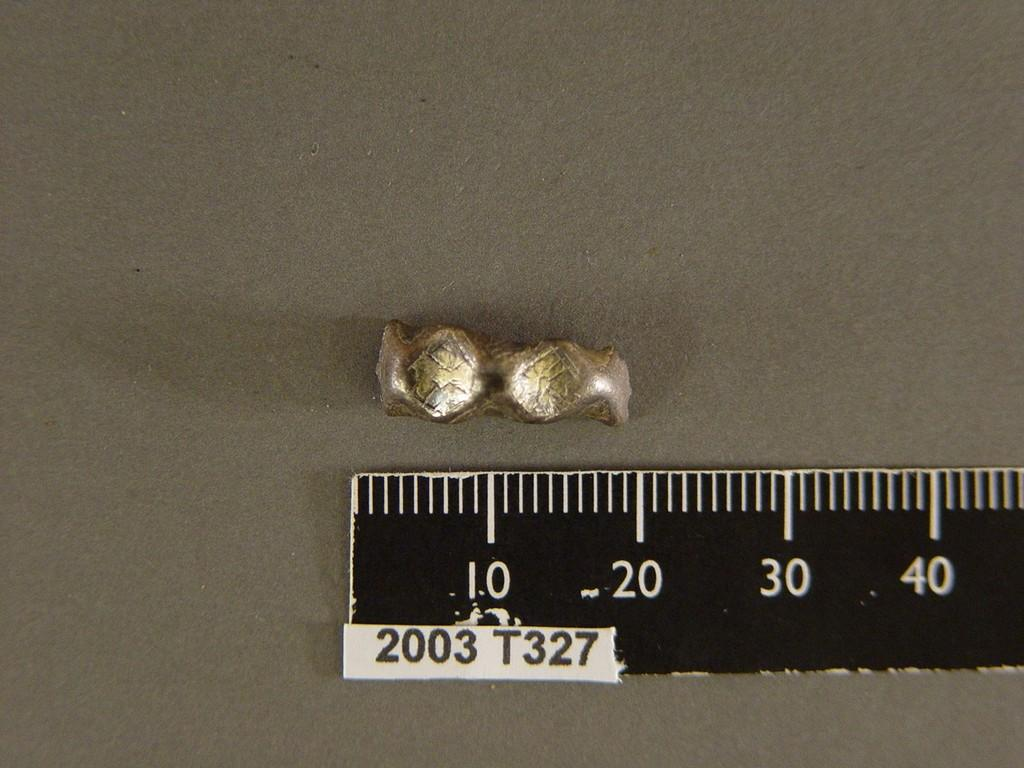<image>
Write a terse but informative summary of the picture. A piece of metal next to a ruler with 2003 T327 on it. 